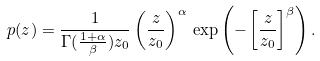Convert formula to latex. <formula><loc_0><loc_0><loc_500><loc_500>p ( z ) = \frac { 1 } { \Gamma ( \frac { 1 + \alpha } { \beta } ) z _ { 0 } } \left ( \frac { z } { z _ { 0 } } \right ) ^ { \alpha } \, \exp { \left ( - \left [ \frac { z } { z _ { 0 } } \right ] ^ { \beta } \right ) } \, .</formula> 